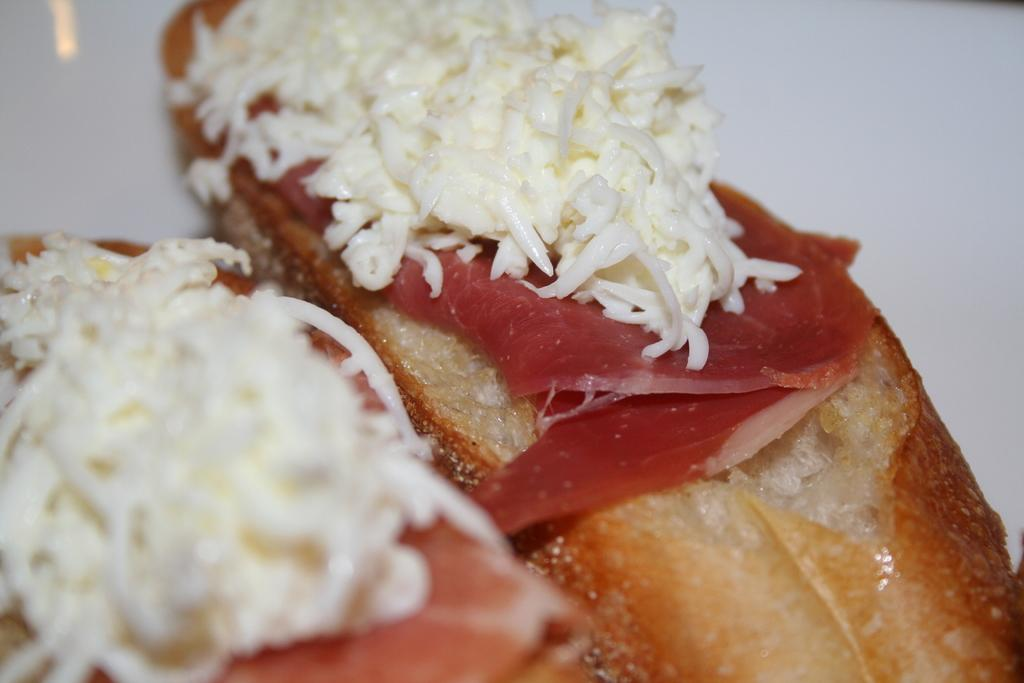What can be seen in the image? There are food items arranged in the image. What color is the background of the image? The background of the image is white. Can you read the writing on the food items in the image? There is no writing present on the food items in the image. 